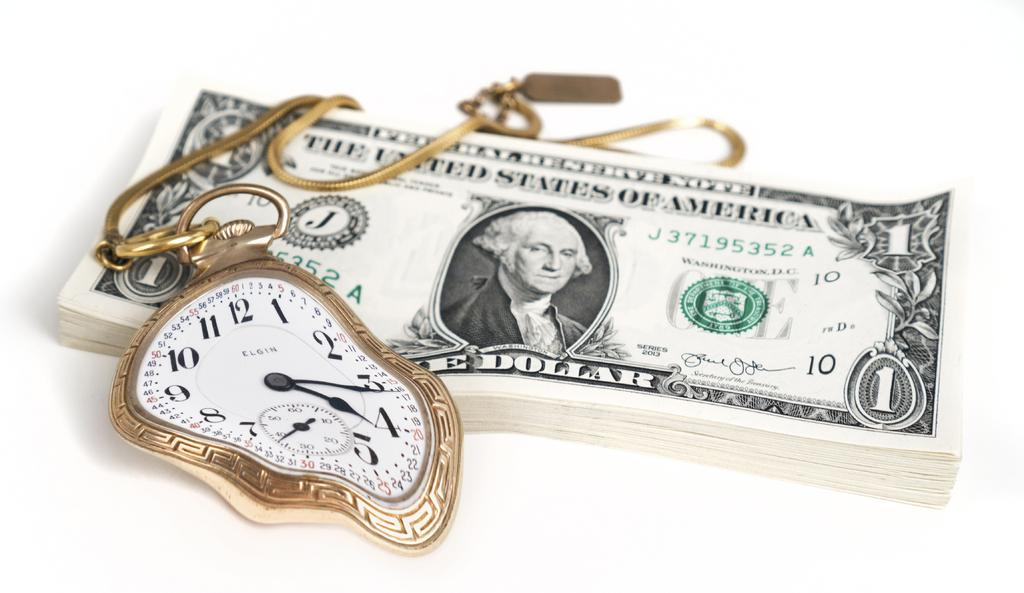Provide a one-sentence caption for the provided image. An Elgin pocket watch sits on a stack of one dollar bills. 